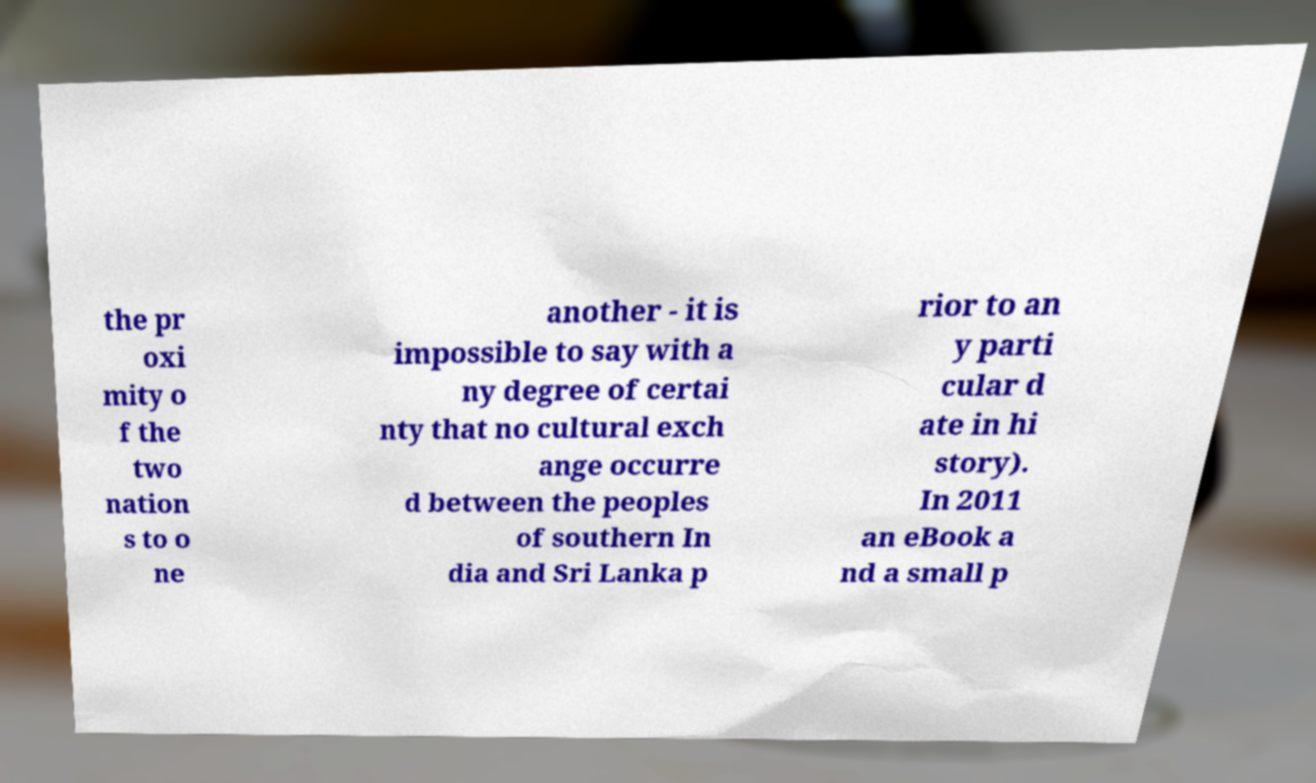Please identify and transcribe the text found in this image. the pr oxi mity o f the two nation s to o ne another - it is impossible to say with a ny degree of certai nty that no cultural exch ange occurre d between the peoples of southern In dia and Sri Lanka p rior to an y parti cular d ate in hi story). In 2011 an eBook a nd a small p 